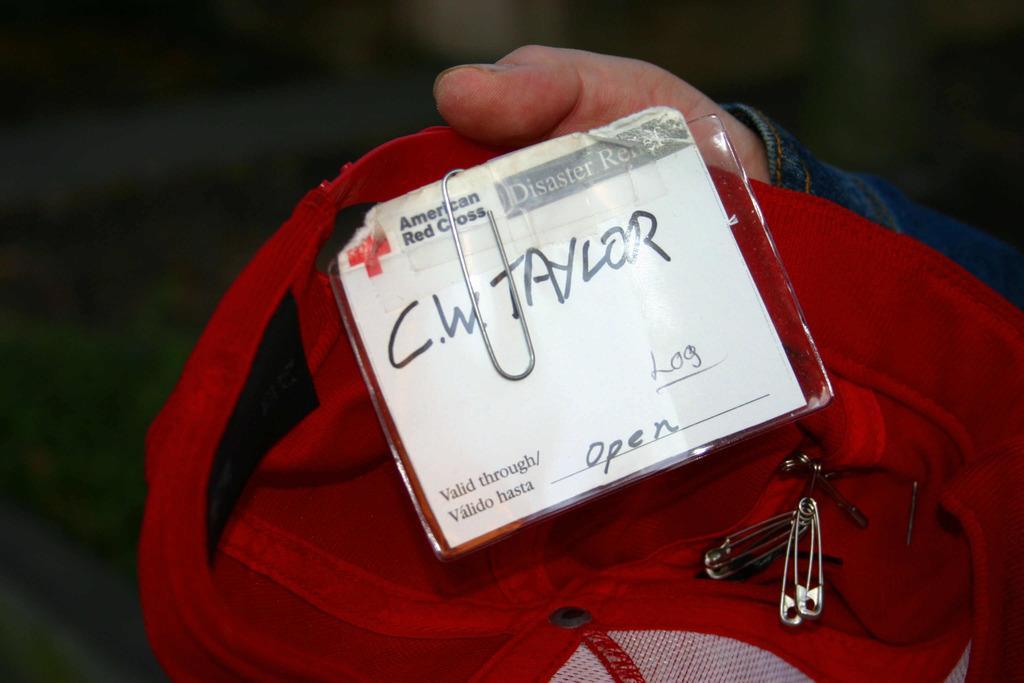How would you summarize this image in a sentence or two? In the picture we can see a person hand holding a red color bag with some pin to it and a card written on it as C. W. Taylor. 